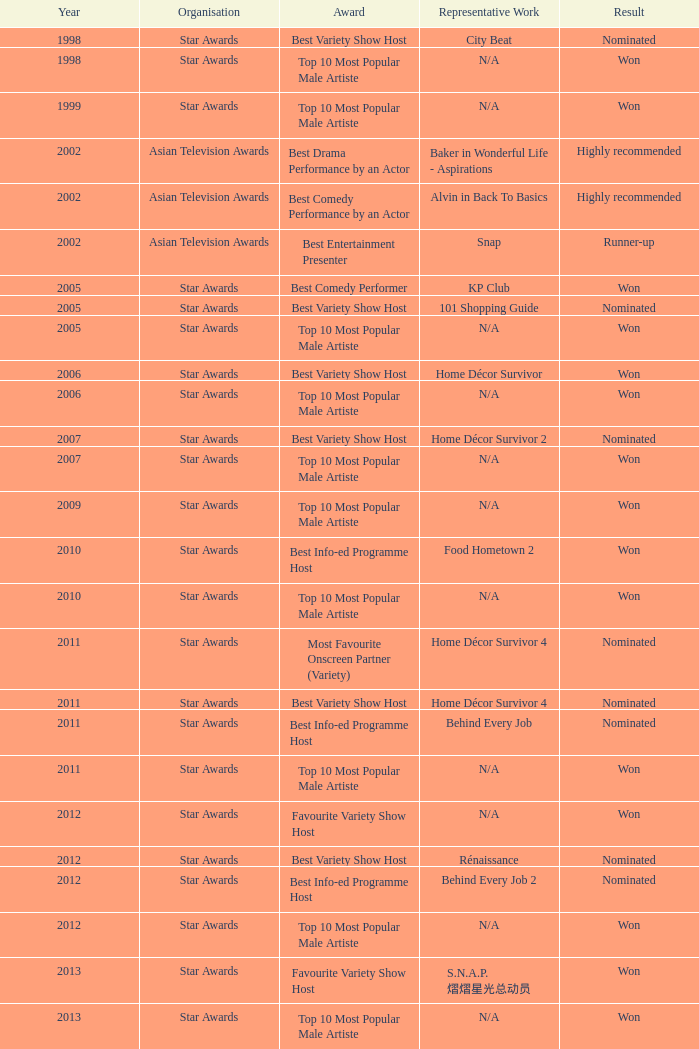What is the name of the award in a year more than 2005, and the Result of nominated? Best Variety Show Host, Most Favourite Onscreen Partner (Variety), Best Variety Show Host, Best Info-ed Programme Host, Best Variety Show Host, Best Info-ed Programme Host, Best Info-Ed Programme Host, Best Variety Show Host. 